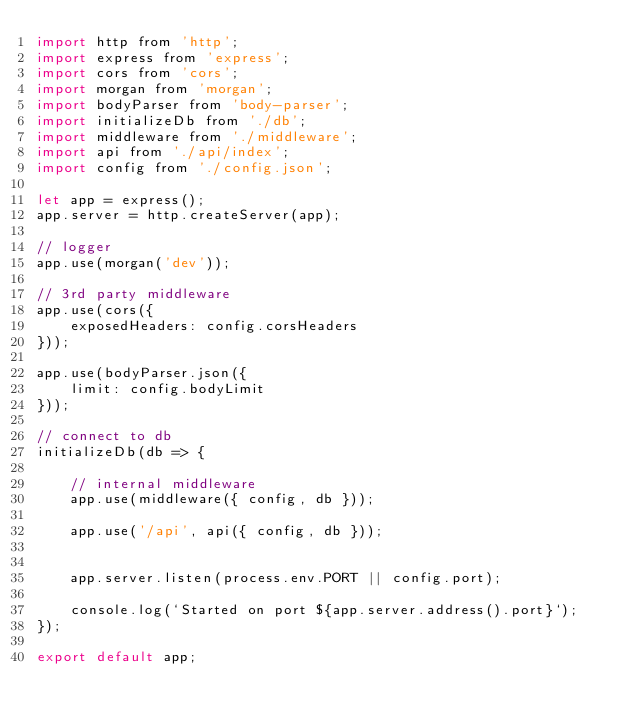<code> <loc_0><loc_0><loc_500><loc_500><_JavaScript_>import http from 'http';
import express from 'express';
import cors from 'cors';
import morgan from 'morgan';
import bodyParser from 'body-parser';
import initializeDb from './db';
import middleware from './middleware';
import api from './api/index';
import config from './config.json';

let app = express();
app.server = http.createServer(app);

// logger
app.use(morgan('dev'));

// 3rd party middleware
app.use(cors({
    exposedHeaders: config.corsHeaders
}));

app.use(bodyParser.json({
    limit: config.bodyLimit
}));

// connect to db
initializeDb(db => {

    // internal middleware
    app.use(middleware({ config, db }));

    app.use('/api', api({ config, db }));


    app.server.listen(process.env.PORT || config.port);

    console.log(`Started on port ${app.server.address().port}`);
});

export default app;
</code> 